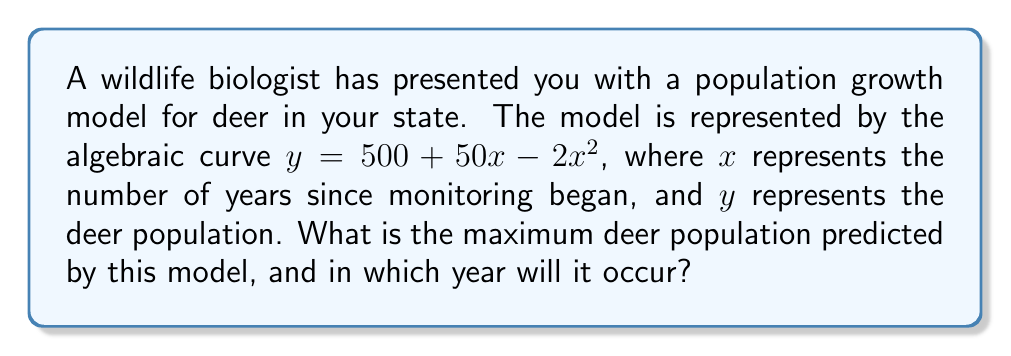What is the answer to this math problem? To solve this problem, we'll follow these steps:

1) The given equation represents a quadratic function: $y = 500 + 50x - 2x^2$

2) To find the maximum value of a quadratic function, we need to find the vertex of the parabola. For a quadratic function in the form $y = ax^2 + bx + c$, the x-coordinate of the vertex is given by $x = -\frac{b}{2a}$

3) In our case, $a = -2$, $b = 50$, and $c = 500$

4) Let's calculate the x-coordinate of the vertex:

   $x = -\frac{50}{2(-2)} = -\frac{50}{-4} = \frac{50}{4} = 12.5$

5) This means the maximum population will occur 12.5 years after monitoring began. Since we're dealing with whole years, we'll round this to 13 years.

6) To find the maximum population (y-coordinate of the vertex), we substitute x = 12.5 into the original equation:

   $y = 500 + 50(12.5) - 2(12.5)^2$
   $= 500 + 625 - 2(156.25)$
   $= 1125 - 312.5$
   $= 812.5$

7) Rounding to the nearest whole number (as we can't have a fraction of a deer), the maximum population is 813 deer.
Answer: 813 deer, occurring 13 years after monitoring began 